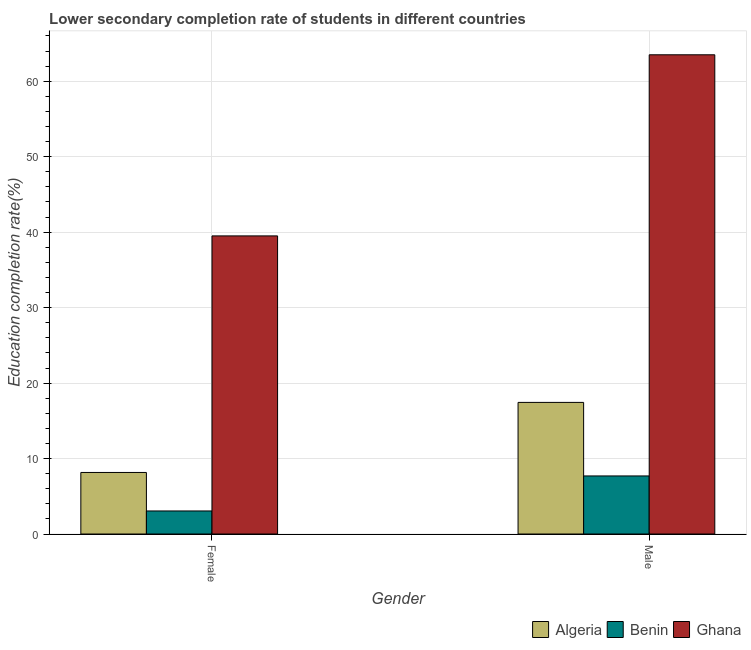Are the number of bars per tick equal to the number of legend labels?
Provide a succinct answer. Yes. How many bars are there on the 1st tick from the left?
Keep it short and to the point. 3. What is the label of the 2nd group of bars from the left?
Offer a very short reply. Male. What is the education completion rate of male students in Algeria?
Provide a short and direct response. 17.44. Across all countries, what is the maximum education completion rate of male students?
Your response must be concise. 63.51. Across all countries, what is the minimum education completion rate of female students?
Provide a short and direct response. 3.05. In which country was the education completion rate of male students maximum?
Make the answer very short. Ghana. In which country was the education completion rate of female students minimum?
Ensure brevity in your answer.  Benin. What is the total education completion rate of female students in the graph?
Keep it short and to the point. 50.72. What is the difference between the education completion rate of female students in Benin and that in Algeria?
Your answer should be very brief. -5.1. What is the difference between the education completion rate of female students in Ghana and the education completion rate of male students in Algeria?
Make the answer very short. 22.07. What is the average education completion rate of male students per country?
Provide a succinct answer. 29.55. What is the difference between the education completion rate of male students and education completion rate of female students in Benin?
Keep it short and to the point. 4.64. In how many countries, is the education completion rate of male students greater than 8 %?
Give a very brief answer. 2. What is the ratio of the education completion rate of male students in Algeria to that in Benin?
Provide a succinct answer. 2.27. Is the education completion rate of male students in Benin less than that in Ghana?
Make the answer very short. Yes. In how many countries, is the education completion rate of male students greater than the average education completion rate of male students taken over all countries?
Your response must be concise. 1. What does the 1st bar from the left in Female represents?
Your answer should be compact. Algeria. What does the 1st bar from the right in Male represents?
Your answer should be very brief. Ghana. How many countries are there in the graph?
Provide a succinct answer. 3. Are the values on the major ticks of Y-axis written in scientific E-notation?
Give a very brief answer. No. How are the legend labels stacked?
Offer a very short reply. Horizontal. What is the title of the graph?
Provide a short and direct response. Lower secondary completion rate of students in different countries. What is the label or title of the Y-axis?
Your answer should be very brief. Education completion rate(%). What is the Education completion rate(%) of Algeria in Female?
Offer a terse response. 8.16. What is the Education completion rate(%) in Benin in Female?
Provide a succinct answer. 3.05. What is the Education completion rate(%) of Ghana in Female?
Ensure brevity in your answer.  39.51. What is the Education completion rate(%) of Algeria in Male?
Keep it short and to the point. 17.44. What is the Education completion rate(%) in Benin in Male?
Offer a terse response. 7.7. What is the Education completion rate(%) in Ghana in Male?
Provide a succinct answer. 63.51. Across all Gender, what is the maximum Education completion rate(%) in Algeria?
Your response must be concise. 17.44. Across all Gender, what is the maximum Education completion rate(%) in Benin?
Give a very brief answer. 7.7. Across all Gender, what is the maximum Education completion rate(%) in Ghana?
Make the answer very short. 63.51. Across all Gender, what is the minimum Education completion rate(%) of Algeria?
Give a very brief answer. 8.16. Across all Gender, what is the minimum Education completion rate(%) of Benin?
Make the answer very short. 3.05. Across all Gender, what is the minimum Education completion rate(%) of Ghana?
Make the answer very short. 39.51. What is the total Education completion rate(%) of Algeria in the graph?
Your answer should be very brief. 25.6. What is the total Education completion rate(%) in Benin in the graph?
Offer a terse response. 10.75. What is the total Education completion rate(%) of Ghana in the graph?
Your answer should be very brief. 103.02. What is the difference between the Education completion rate(%) of Algeria in Female and that in Male?
Your answer should be compact. -9.29. What is the difference between the Education completion rate(%) of Benin in Female and that in Male?
Give a very brief answer. -4.64. What is the difference between the Education completion rate(%) in Ghana in Female and that in Male?
Your response must be concise. -24. What is the difference between the Education completion rate(%) in Algeria in Female and the Education completion rate(%) in Benin in Male?
Your answer should be compact. 0.46. What is the difference between the Education completion rate(%) of Algeria in Female and the Education completion rate(%) of Ghana in Male?
Provide a succinct answer. -55.35. What is the difference between the Education completion rate(%) in Benin in Female and the Education completion rate(%) in Ghana in Male?
Your answer should be compact. -60.46. What is the average Education completion rate(%) of Algeria per Gender?
Keep it short and to the point. 12.8. What is the average Education completion rate(%) in Benin per Gender?
Offer a very short reply. 5.37. What is the average Education completion rate(%) of Ghana per Gender?
Provide a succinct answer. 51.51. What is the difference between the Education completion rate(%) of Algeria and Education completion rate(%) of Benin in Female?
Keep it short and to the point. 5.1. What is the difference between the Education completion rate(%) in Algeria and Education completion rate(%) in Ghana in Female?
Your response must be concise. -31.35. What is the difference between the Education completion rate(%) in Benin and Education completion rate(%) in Ghana in Female?
Ensure brevity in your answer.  -36.45. What is the difference between the Education completion rate(%) in Algeria and Education completion rate(%) in Benin in Male?
Make the answer very short. 9.75. What is the difference between the Education completion rate(%) in Algeria and Education completion rate(%) in Ghana in Male?
Keep it short and to the point. -46.07. What is the difference between the Education completion rate(%) in Benin and Education completion rate(%) in Ghana in Male?
Keep it short and to the point. -55.81. What is the ratio of the Education completion rate(%) of Algeria in Female to that in Male?
Your response must be concise. 0.47. What is the ratio of the Education completion rate(%) in Benin in Female to that in Male?
Make the answer very short. 0.4. What is the ratio of the Education completion rate(%) of Ghana in Female to that in Male?
Offer a very short reply. 0.62. What is the difference between the highest and the second highest Education completion rate(%) in Algeria?
Your response must be concise. 9.29. What is the difference between the highest and the second highest Education completion rate(%) in Benin?
Give a very brief answer. 4.64. What is the difference between the highest and the second highest Education completion rate(%) in Ghana?
Your response must be concise. 24. What is the difference between the highest and the lowest Education completion rate(%) of Algeria?
Provide a succinct answer. 9.29. What is the difference between the highest and the lowest Education completion rate(%) of Benin?
Offer a terse response. 4.64. What is the difference between the highest and the lowest Education completion rate(%) in Ghana?
Offer a terse response. 24. 